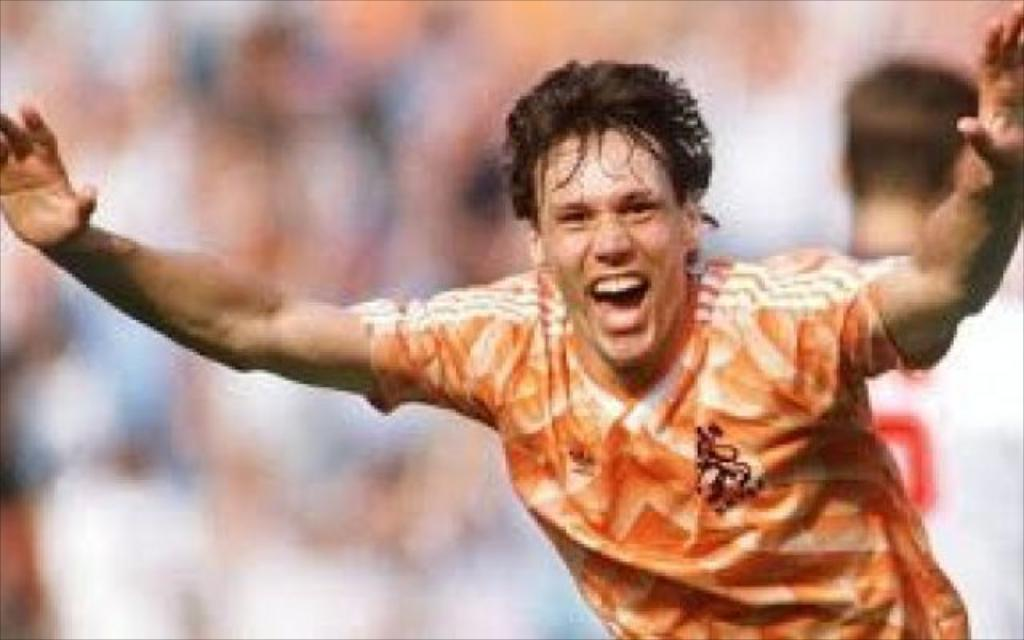How many people are present in the image? There are two people in the image. What are the people wearing? The people are wearing jerseys. Can you describe the background of the image? The background of the image is blurred. What type of apple can be seen on the skin of one of the people in the image? There is no apple or skin visible on any of the people in the image. How many roses are present in the image? There are no roses present in the image. 